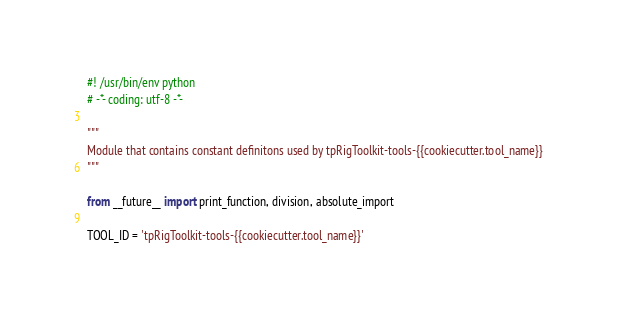Convert code to text. <code><loc_0><loc_0><loc_500><loc_500><_Python_>#! /usr/bin/env python
# -*- coding: utf-8 -*-

"""
Module that contains constant definitons used by tpRigToolkit-tools-{{cookiecutter.tool_name}}
"""

from __future__ import print_function, division, absolute_import

TOOL_ID = 'tpRigToolkit-tools-{{cookiecutter.tool_name}}'
</code> 